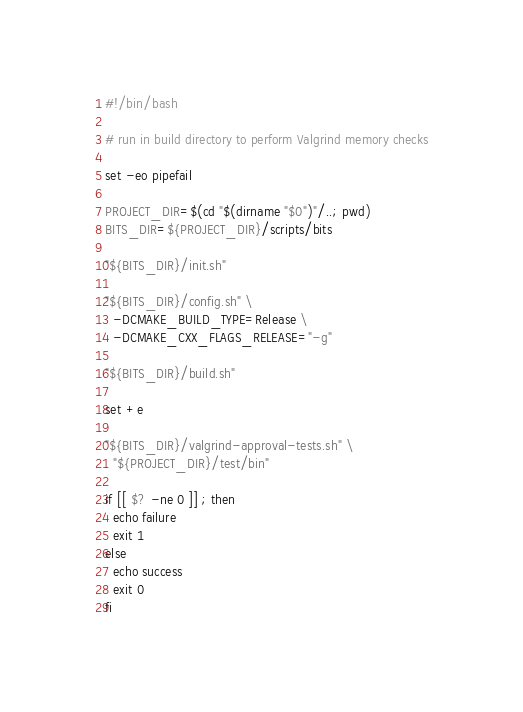Convert code to text. <code><loc_0><loc_0><loc_500><loc_500><_Bash_>#!/bin/bash

# run in build directory to perform Valgrind memory checks

set -eo pipefail

PROJECT_DIR=$(cd "$(dirname "$0")"/..; pwd)
BITS_DIR=${PROJECT_DIR}/scripts/bits

"${BITS_DIR}/init.sh"

"${BITS_DIR}/config.sh" \
  -DCMAKE_BUILD_TYPE=Release \
  -DCMAKE_CXX_FLAGS_RELEASE="-g"

"${BITS_DIR}/build.sh"

set +e

"${BITS_DIR}/valgrind-approval-tests.sh" \
  "${PROJECT_DIR}/test/bin"

if [[ $? -ne 0 ]] ; then
  echo failure
  exit 1
else
  echo success
  exit 0
fi
</code> 